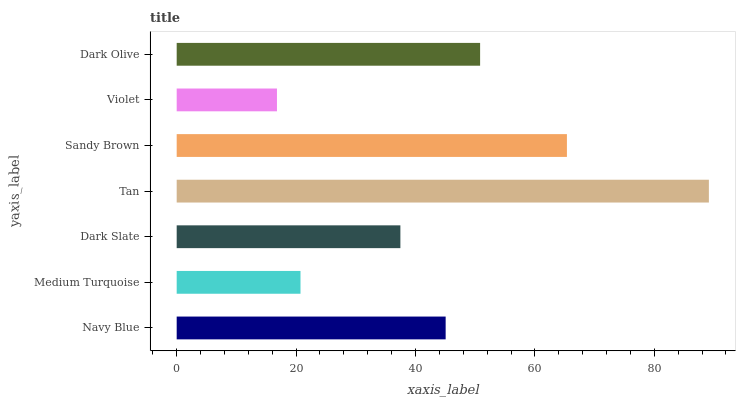Is Violet the minimum?
Answer yes or no. Yes. Is Tan the maximum?
Answer yes or no. Yes. Is Medium Turquoise the minimum?
Answer yes or no. No. Is Medium Turquoise the maximum?
Answer yes or no. No. Is Navy Blue greater than Medium Turquoise?
Answer yes or no. Yes. Is Medium Turquoise less than Navy Blue?
Answer yes or no. Yes. Is Medium Turquoise greater than Navy Blue?
Answer yes or no. No. Is Navy Blue less than Medium Turquoise?
Answer yes or no. No. Is Navy Blue the high median?
Answer yes or no. Yes. Is Navy Blue the low median?
Answer yes or no. Yes. Is Dark Slate the high median?
Answer yes or no. No. Is Medium Turquoise the low median?
Answer yes or no. No. 